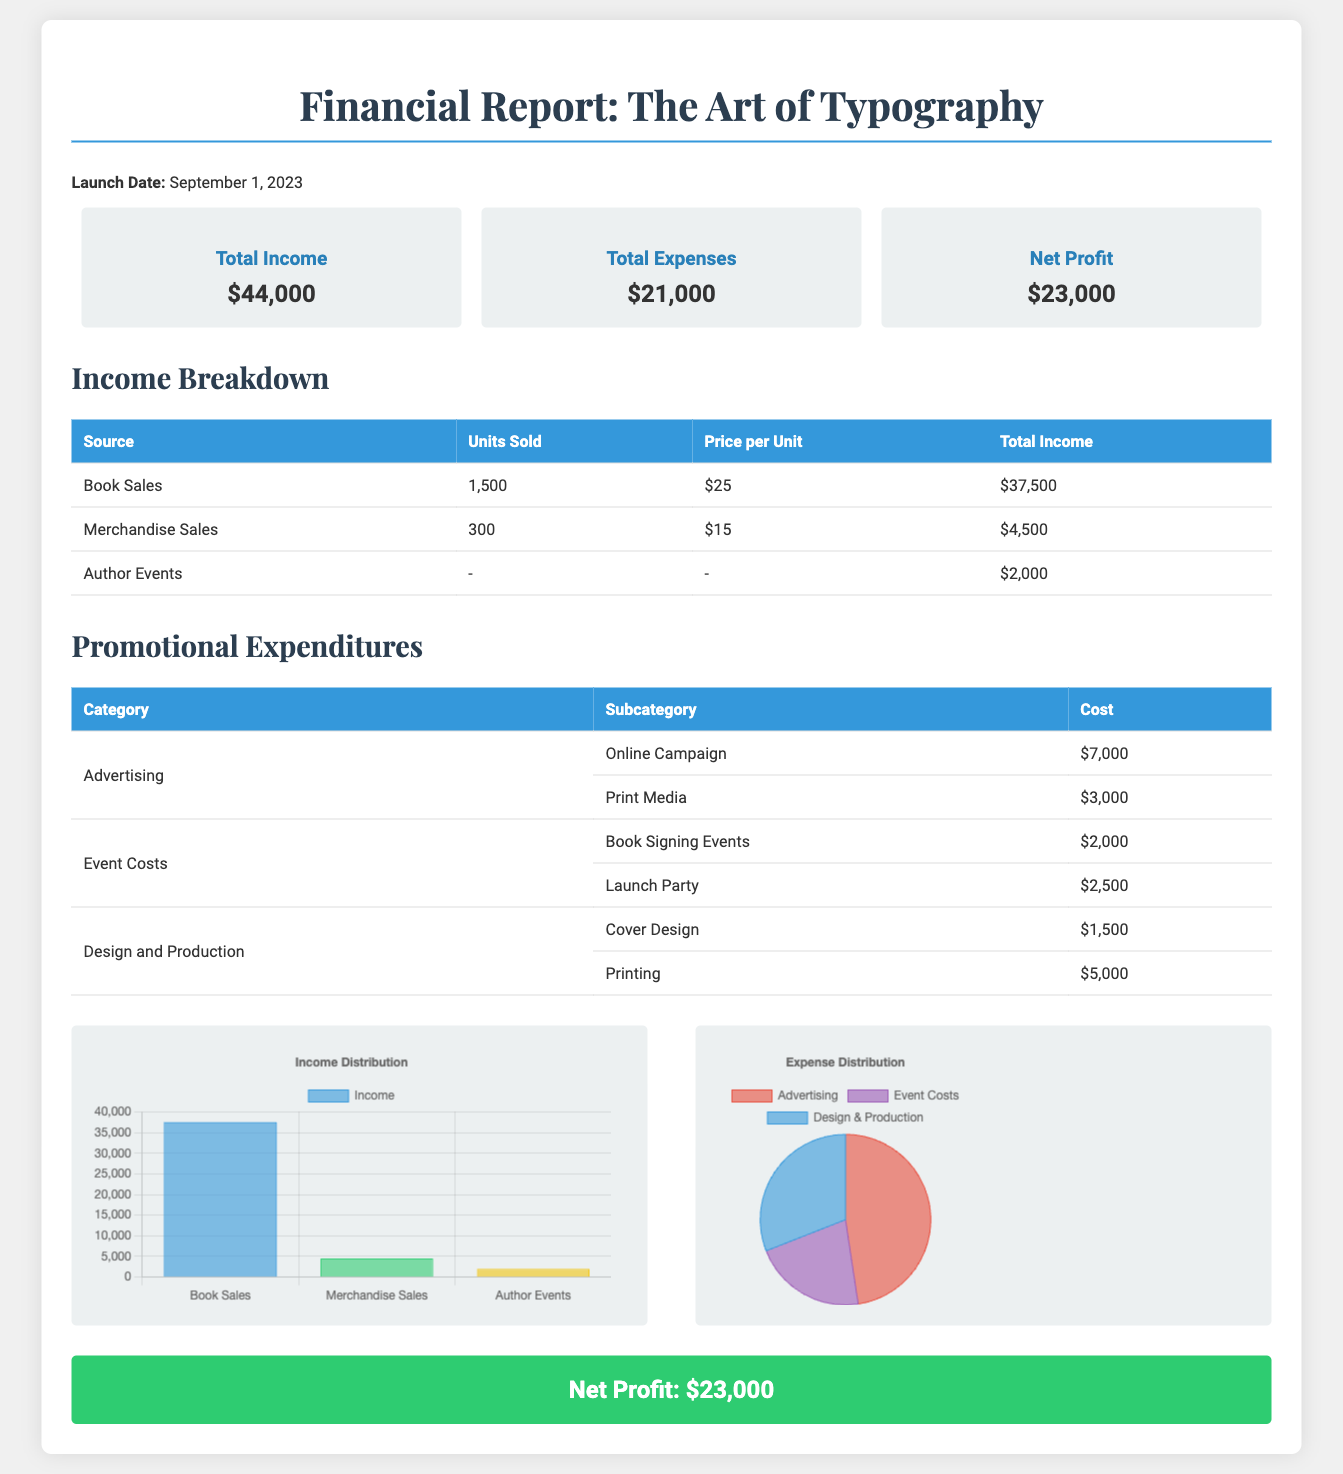What is the launch date of the book? The launch date of the book is mentioned at the beginning of the document as September 1, 2023.
Answer: September 1, 2023 What is the total income from book sales? The total income from book sales is detailed in the Income Breakdown table as $37,500.
Answer: $37,500 How much was spent on advertising? The promotional expenditures detail shows that the total cost for advertising is $10,000 ($7,000 for Online Campaign and $3,000 for Print Media).
Answer: $10,000 What is the net profit reported? The net profit is summarized at the end of the report and stated as $23,000.
Answer: $23,000 How many units of merchandise were sold? The Income Breakdown table specifies that 300 units of merchandise were sold.
Answer: 300 What category had the highest expenses? By examining the expenditures table, Advertising had the highest total cost of $10,000.
Answer: Advertising What is the total amount spent on event costs? The total for event costs is shown as $4,500 ($2,000 for Book Signing Events and $2,500 for Launch Party).
Answer: $4,500 What type of chart represents the income distribution? The income distribution is represented using a bar chart as mentioned in the script for rendering.
Answer: Bar chart What is the total income from author events? According to the Income Breakdown table, the total income from author events is $2,000.
Answer: $2,000 